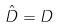<formula> <loc_0><loc_0><loc_500><loc_500>\hat { D } = D</formula> 